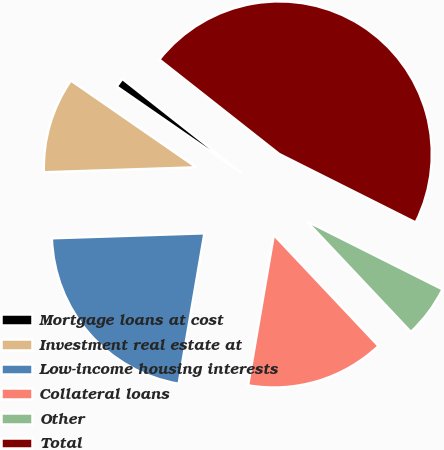Convert chart. <chart><loc_0><loc_0><loc_500><loc_500><pie_chart><fcel>Mortgage loans at cost<fcel>Investment real estate at<fcel>Low-income housing interests<fcel>Collateral loans<fcel>Other<fcel>Total<nl><fcel>0.99%<fcel>10.15%<fcel>21.79%<fcel>14.73%<fcel>5.57%<fcel>46.79%<nl></chart> 